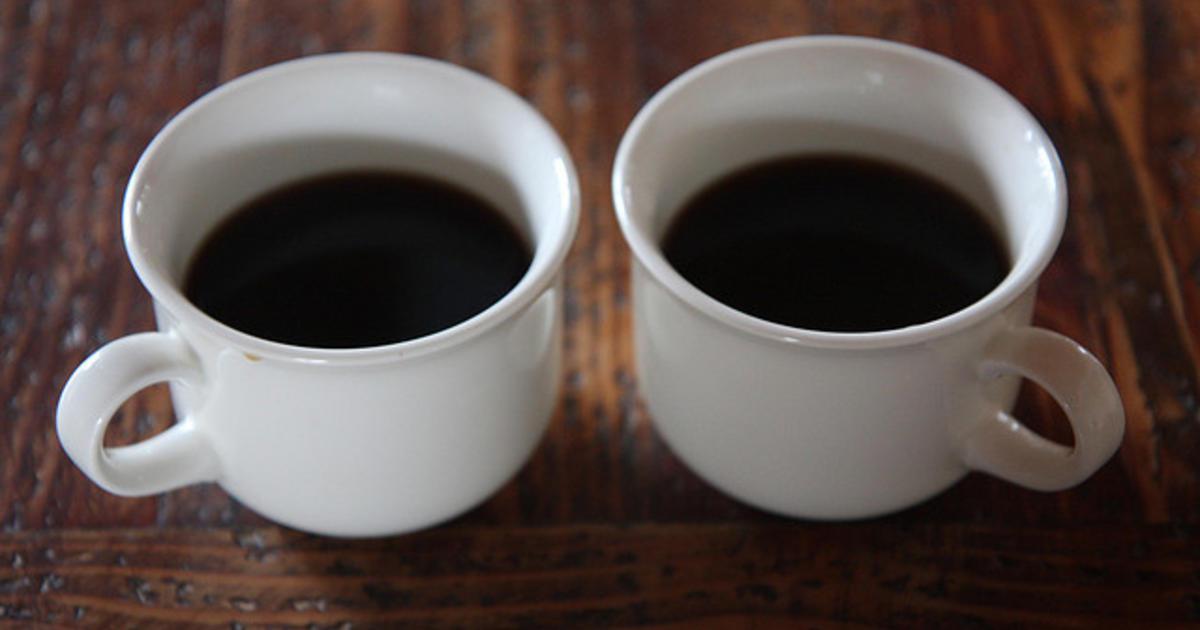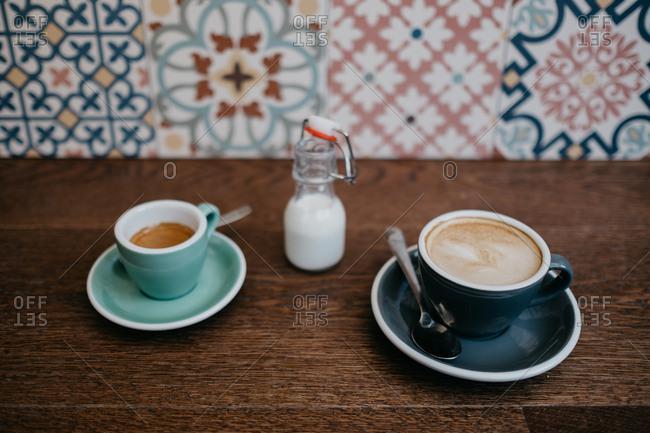The first image is the image on the left, the second image is the image on the right. For the images shown, is this caption "An image shows two cups of beverage, with spoons nearby." true? Answer yes or no. Yes. The first image is the image on the left, the second image is the image on the right. For the images shown, is this caption "There are at least four cups of coffee." true? Answer yes or no. Yes. 